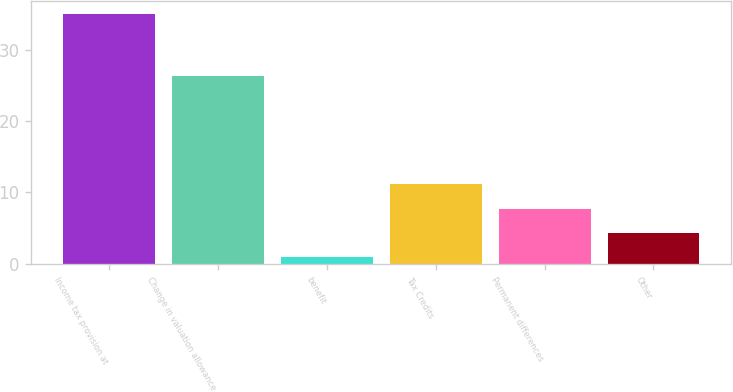Convert chart to OTSL. <chart><loc_0><loc_0><loc_500><loc_500><bar_chart><fcel>Income tax provision at<fcel>Change in valuation allowance<fcel>benefit<fcel>Tax Credits<fcel>Permanent differences<fcel>Other<nl><fcel>35<fcel>26.3<fcel>0.9<fcel>11.13<fcel>7.72<fcel>4.31<nl></chart> 